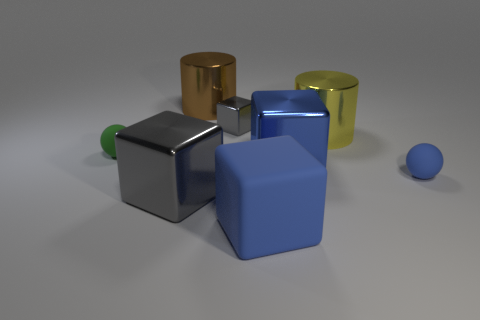How do the textures of the objects differ? The objects exhibit varying textures: the gray cube has a smooth and shiny surface, reflecting its surroundings, while the blue cube looks matte. The disparity in textures adds visual interest to the image. 